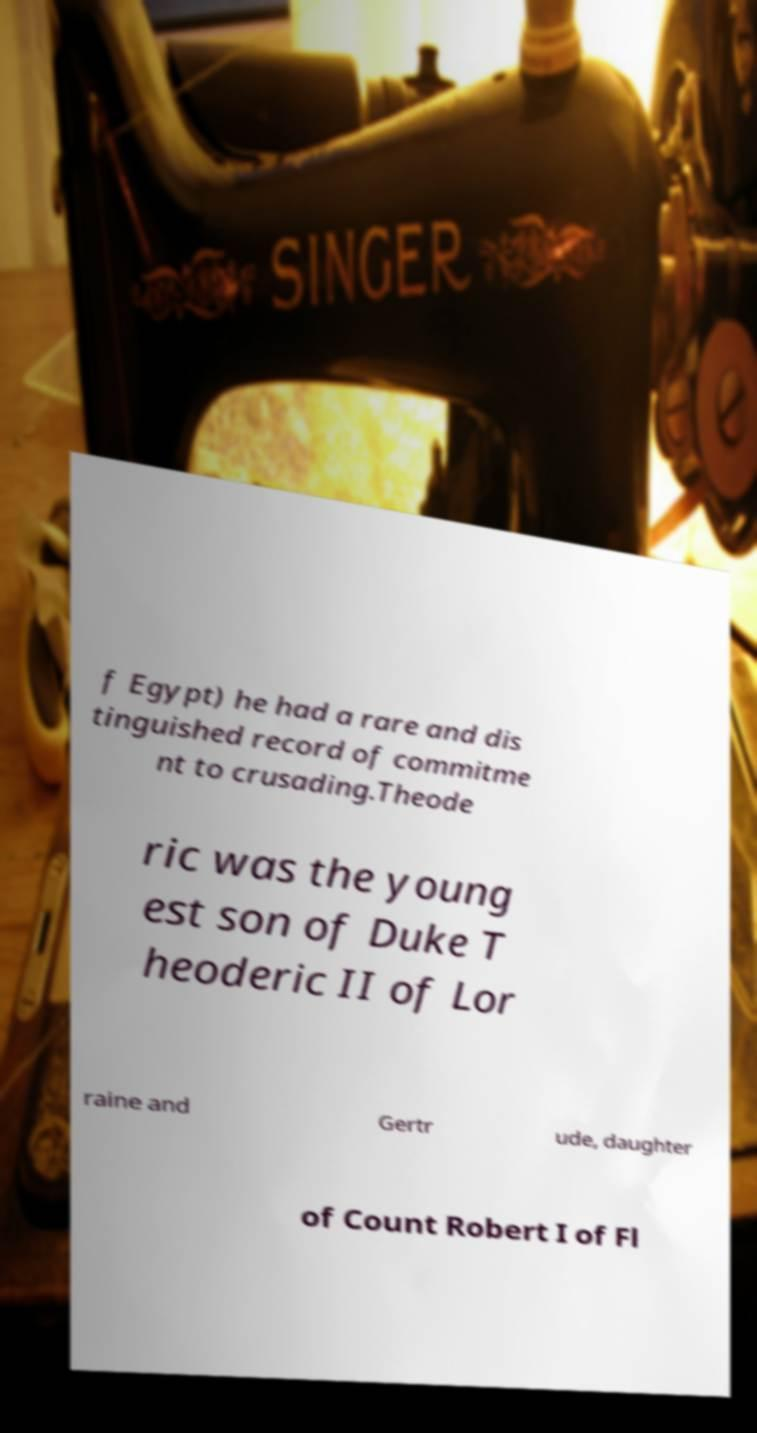Could you assist in decoding the text presented in this image and type it out clearly? f Egypt) he had a rare and dis tinguished record of commitme nt to crusading.Theode ric was the young est son of Duke T heoderic II of Lor raine and Gertr ude, daughter of Count Robert I of Fl 